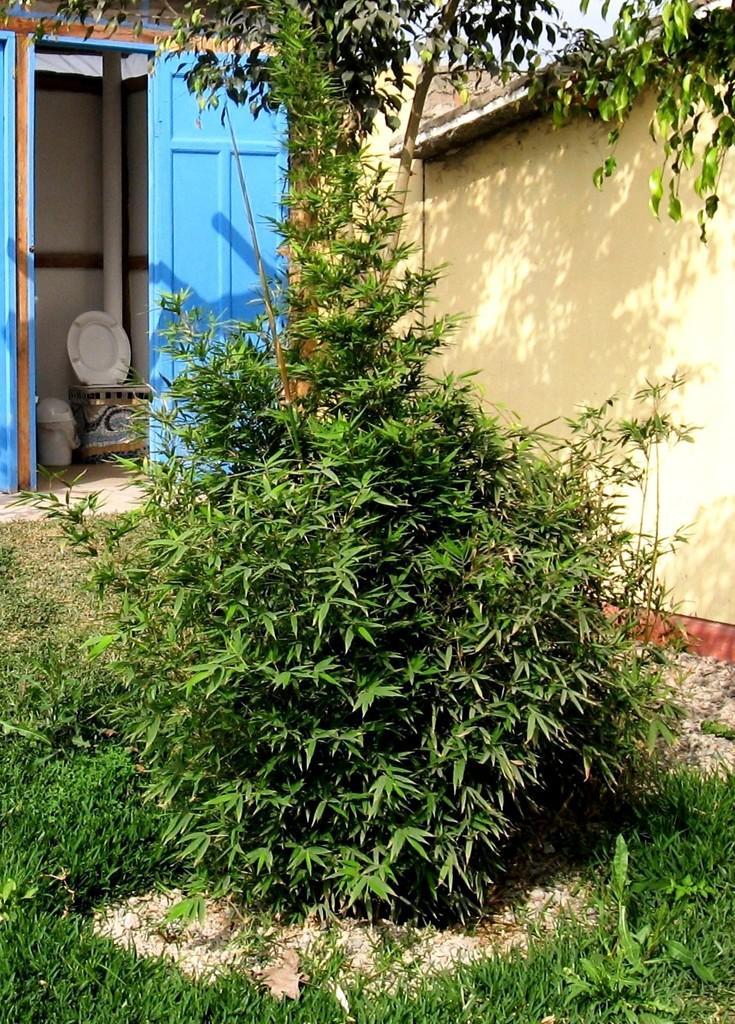How would you summarize this image in a sentence or two? In this image we can see ground, plants, tree, walls, pipeline, toilet seat, bin, door and sky. 